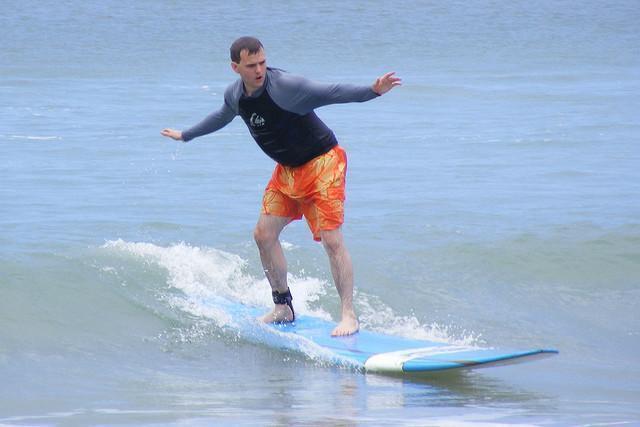How many orange cats are there in the image?
Give a very brief answer. 0. 